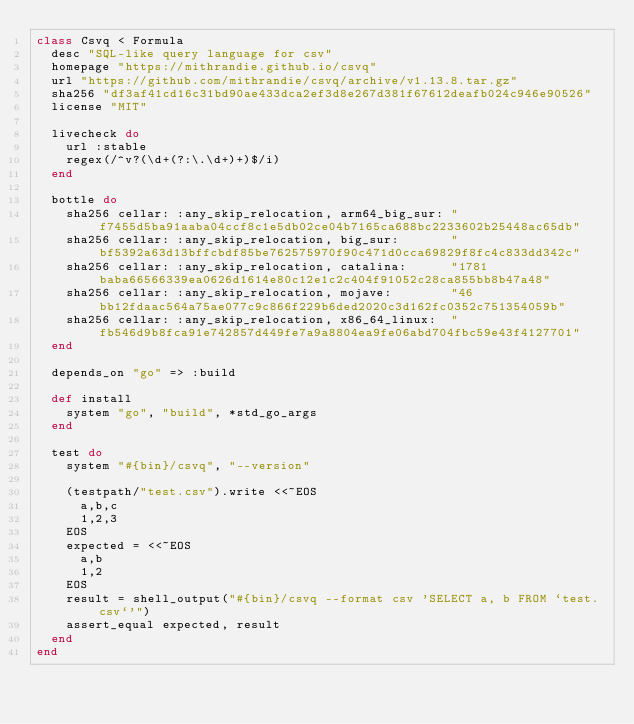Convert code to text. <code><loc_0><loc_0><loc_500><loc_500><_Ruby_>class Csvq < Formula
  desc "SQL-like query language for csv"
  homepage "https://mithrandie.github.io/csvq"
  url "https://github.com/mithrandie/csvq/archive/v1.13.8.tar.gz"
  sha256 "df3af41cd16c31bd90ae433dca2ef3d8e267d381f67612deafb024c946e90526"
  license "MIT"

  livecheck do
    url :stable
    regex(/^v?(\d+(?:\.\d+)+)$/i)
  end

  bottle do
    sha256 cellar: :any_skip_relocation, arm64_big_sur: "f7455d5ba91aaba04ccf8c1e5db02ce04b7165ca688bc2233602b25448ac65db"
    sha256 cellar: :any_skip_relocation, big_sur:       "bf5392a63d13bffcbdf85be762575970f90c471d0cca69829f8fc4c833dd342c"
    sha256 cellar: :any_skip_relocation, catalina:      "1781baba66566339ea0626d1614e80c12e1c2c404f91052c28ca855bb8b47a48"
    sha256 cellar: :any_skip_relocation, mojave:        "46bb12fdaac564a75ae077c9c866f229b6ded2020c3d162fc0352c751354059b"
    sha256 cellar: :any_skip_relocation, x86_64_linux:  "fb546d9b8fca91e742857d449fe7a9a8804ea9fe06abd704fbc59e43f4127701"
  end

  depends_on "go" => :build

  def install
    system "go", "build", *std_go_args
  end

  test do
    system "#{bin}/csvq", "--version"

    (testpath/"test.csv").write <<~EOS
      a,b,c
      1,2,3
    EOS
    expected = <<~EOS
      a,b
      1,2
    EOS
    result = shell_output("#{bin}/csvq --format csv 'SELECT a, b FROM `test.csv`'")
    assert_equal expected, result
  end
end
</code> 